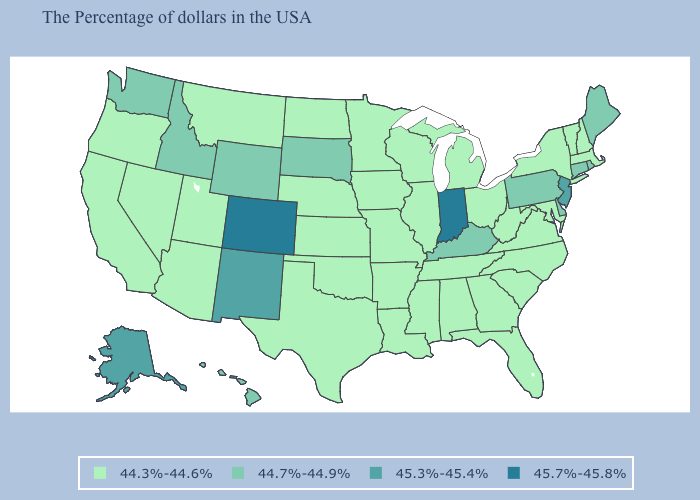What is the value of New Mexico?
Short answer required. 45.3%-45.4%. Name the states that have a value in the range 44.7%-44.9%?
Keep it brief. Maine, Rhode Island, Connecticut, Delaware, Pennsylvania, Kentucky, South Dakota, Wyoming, Idaho, Washington, Hawaii. Name the states that have a value in the range 44.7%-44.9%?
Concise answer only. Maine, Rhode Island, Connecticut, Delaware, Pennsylvania, Kentucky, South Dakota, Wyoming, Idaho, Washington, Hawaii. Name the states that have a value in the range 44.7%-44.9%?
Keep it brief. Maine, Rhode Island, Connecticut, Delaware, Pennsylvania, Kentucky, South Dakota, Wyoming, Idaho, Washington, Hawaii. What is the highest value in the South ?
Keep it brief. 44.7%-44.9%. Name the states that have a value in the range 45.7%-45.8%?
Keep it brief. Indiana, Colorado. What is the value of Louisiana?
Keep it brief. 44.3%-44.6%. What is the lowest value in the USA?
Concise answer only. 44.3%-44.6%. What is the lowest value in the South?
Answer briefly. 44.3%-44.6%. Does Kentucky have the highest value in the South?
Quick response, please. Yes. Which states hav the highest value in the MidWest?
Keep it brief. Indiana. Does Massachusetts have a lower value than Louisiana?
Give a very brief answer. No. Which states have the highest value in the USA?
Keep it brief. Indiana, Colorado. What is the highest value in the USA?
Quick response, please. 45.7%-45.8%. 